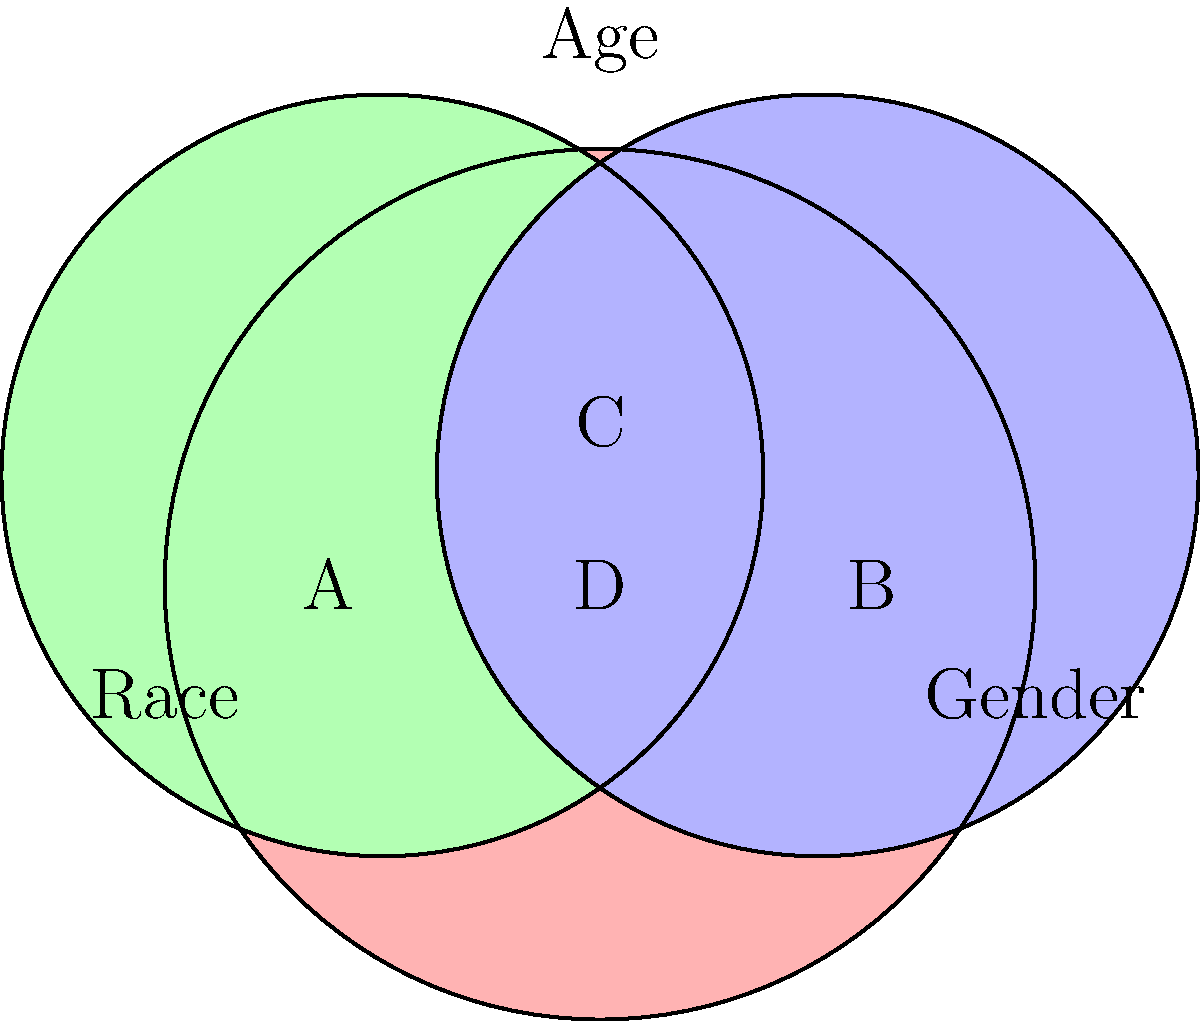In the Venn diagram above, which represents intersectionality in workplace discrimination cases, the overlapping regions indicate instances where multiple forms of discrimination intersect. If region D represents cases involving all three forms of discrimination (race, gender, and age), what percentage of total discrimination cases does it likely represent, and why is this information crucial for a human resources professional? To answer this question, let's break it down step-by-step:

1. The Venn diagram illustrates the intersection of three types of workplace discrimination: race, gender, and age.

2. Region D, at the center where all three circles overlap, represents cases involving all three forms of discrimination simultaneously.

3. While exact percentages can vary depending on the specific workplace or industry, intersectional discrimination cases (region D) typically represent a smaller portion of total discrimination cases. Research suggests this could be around 5-10% of all reported cases.

4. This information is crucial for a human resources professional for several reasons:

   a) Awareness: It highlights the complexity of discrimination and the need to recognize multiple, intersecting forms of bias.
   
   b) Policy development: It informs the creation of more comprehensive anti-discrimination policies that address intersectional issues.
   
   c) Training: It emphasizes the importance of nuanced diversity and inclusion training that covers intersectionality.
   
   d) Case handling: It prepares HR professionals to handle complex cases involving multiple forms of discrimination.
   
   e) Resource allocation: It helps in allocating appropriate resources for addressing and preventing intersectional discrimination.
   
   f) Legal compliance: Understanding intersectionality helps ensure compliance with anti-discrimination laws that may cover multiple protected characteristics.

5. For a highly sensitive HR professional, this information underscores the importance of a holistic approach to addressing workplace discrimination, recognizing that individuals may face compounded disadvantages due to multiple, intersecting identities.
Answer: Approximately 5-10%; crucial for comprehensive anti-discrimination strategies. 